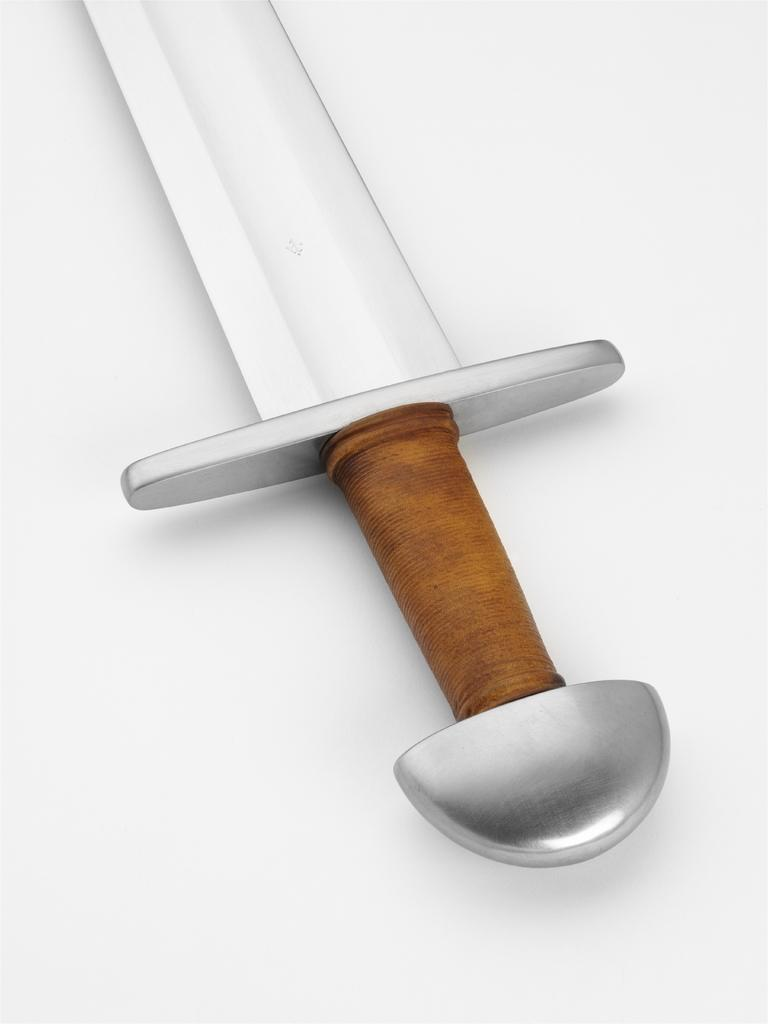What object can be seen in the image? There is a sword in the image. What color is the background of the image? The background of the image is white. Can you tell me how many crackers are on the sword in the image? There are no crackers present in the image, and the sword is not associated with any food items. 